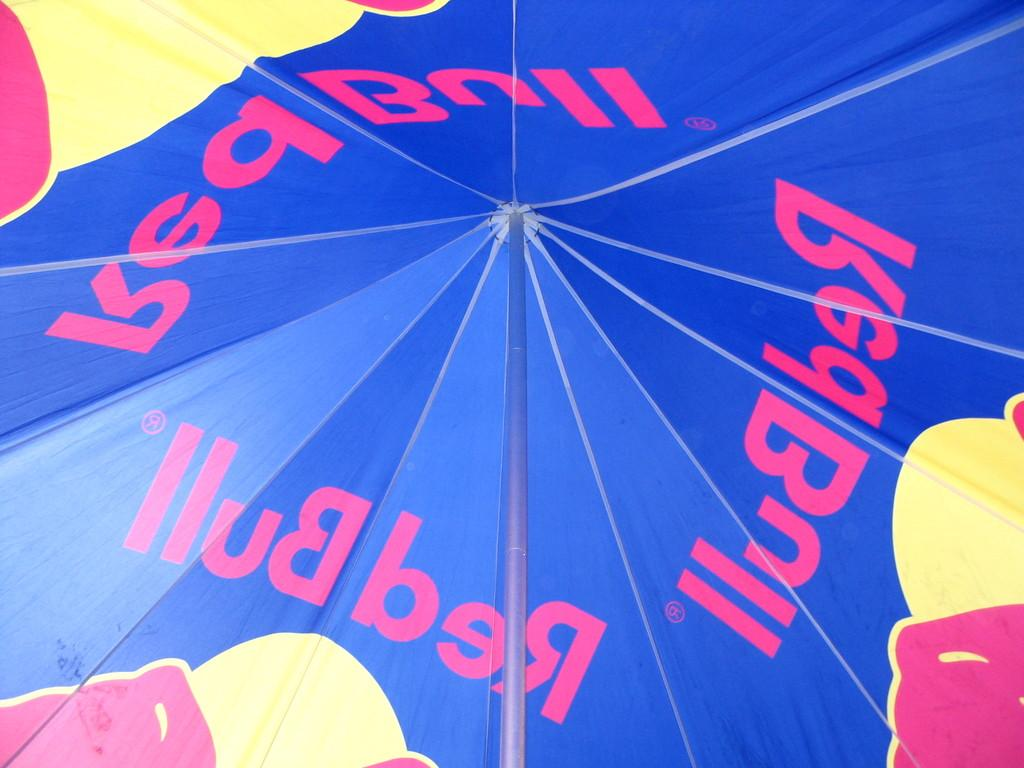What structure is present in the image? There is a tent in the image. What feature can be seen on the tent? The tent has a pole. What type of glove is being used for arithmetic calculations in the image? There is no glove or arithmetic calculations present in the image; it only features a tent with a pole. What vegetable is being used as a support for the tent in the image? There is no vegetable being used as a support for the tent in the image; it is supported by a pole. 